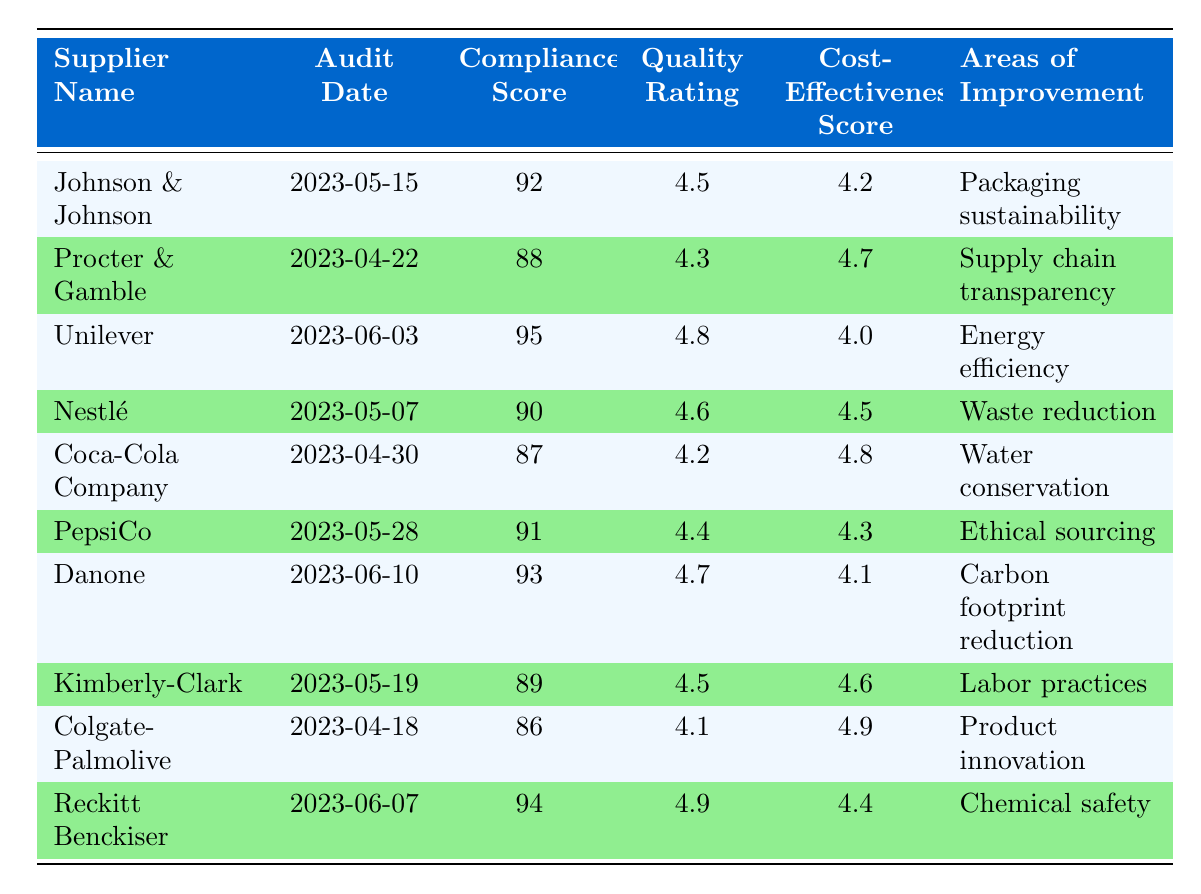What is the compliance score of Procter & Gamble? The compliance score is provided in the table under the corresponding column for Procter & Gamble, which is directly visible.
Answer: 88 Which supplier has the highest Quality Rating? To find the highest quality rating, we compare the values listed in the Quality Rating column. Unilever has the highest value at 4.8.
Answer: Unilever What is the average Cost-Effectiveness Score of all suppliers? First, we sum the Cost-Effectiveness Scores: (4.2 + 4.7 + 4.0 + 4.5 + 4.8 + 4.3 + 4.1 + 4.6 + 4.9 + 4.4) = 46.7. There are 10 suppliers, so the average is 46.7 / 10 = 4.67.
Answer: 4.67 Did Coca-Cola Company receive a compliance score above 90? We check the Compliance Score for Coca-Cola Company, which is 87. Since 87 is not above 90, the answer is no.
Answer: No Which area of improvement is common for any supplier? To determine if there is a common area of improvement, we need to check all entries in the "Areas of Improvement" column. Each supplier has a unique area of improvement, indicating there is no common area.
Answer: None 